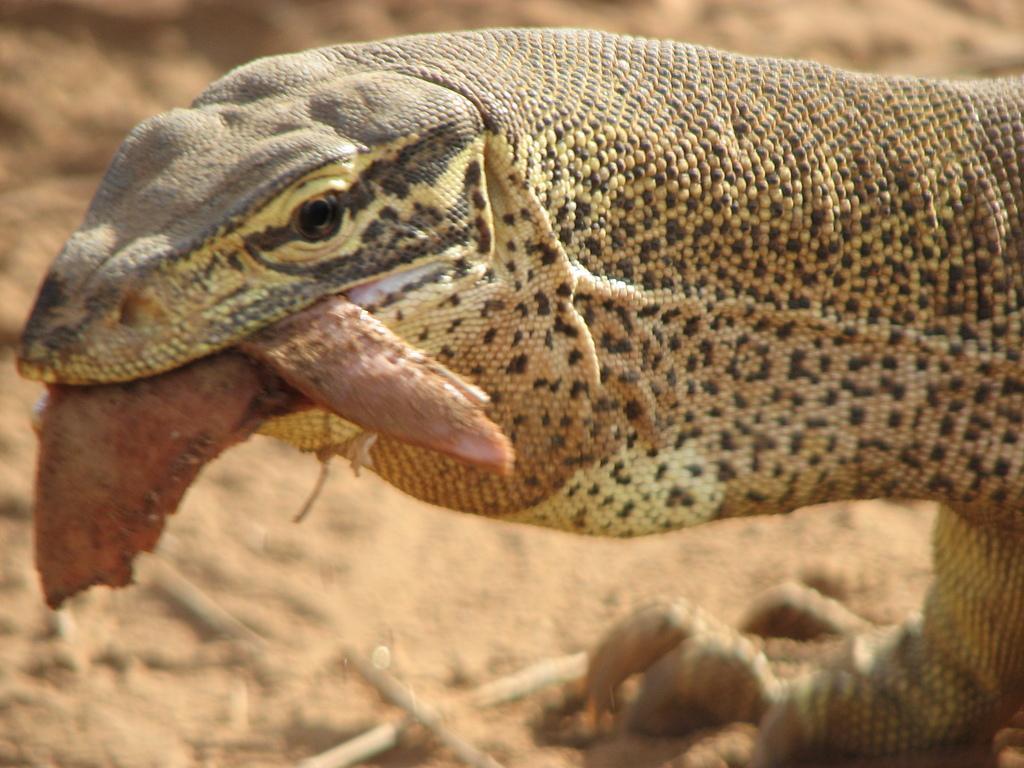Please provide a concise description of this image. In this image I can see a reptile which is in brown and black color. 